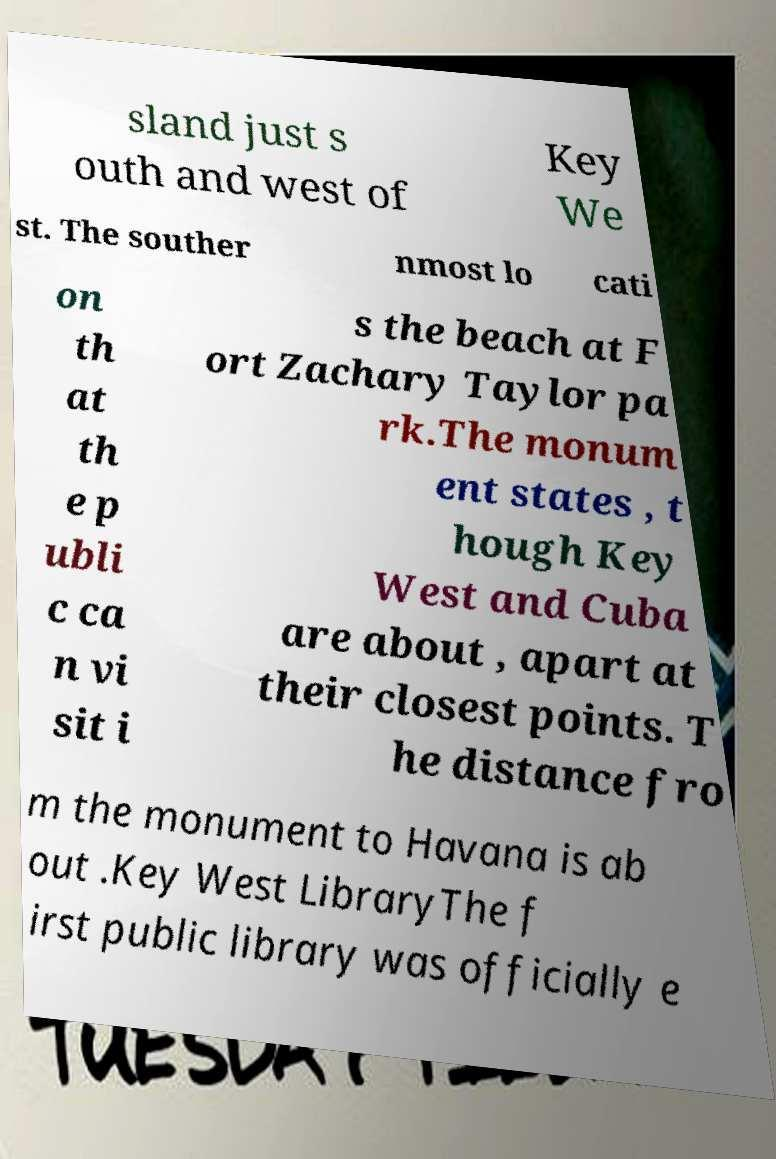Please identify and transcribe the text found in this image. sland just s outh and west of Key We st. The souther nmost lo cati on th at th e p ubli c ca n vi sit i s the beach at F ort Zachary Taylor pa rk.The monum ent states , t hough Key West and Cuba are about , apart at their closest points. T he distance fro m the monument to Havana is ab out .Key West LibraryThe f irst public library was officially e 